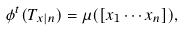<formula> <loc_0><loc_0><loc_500><loc_500>\phi ^ { t } ( T _ { x | n } ) = \mu ( [ x _ { 1 } \cdots x _ { n } ] ) ,</formula> 